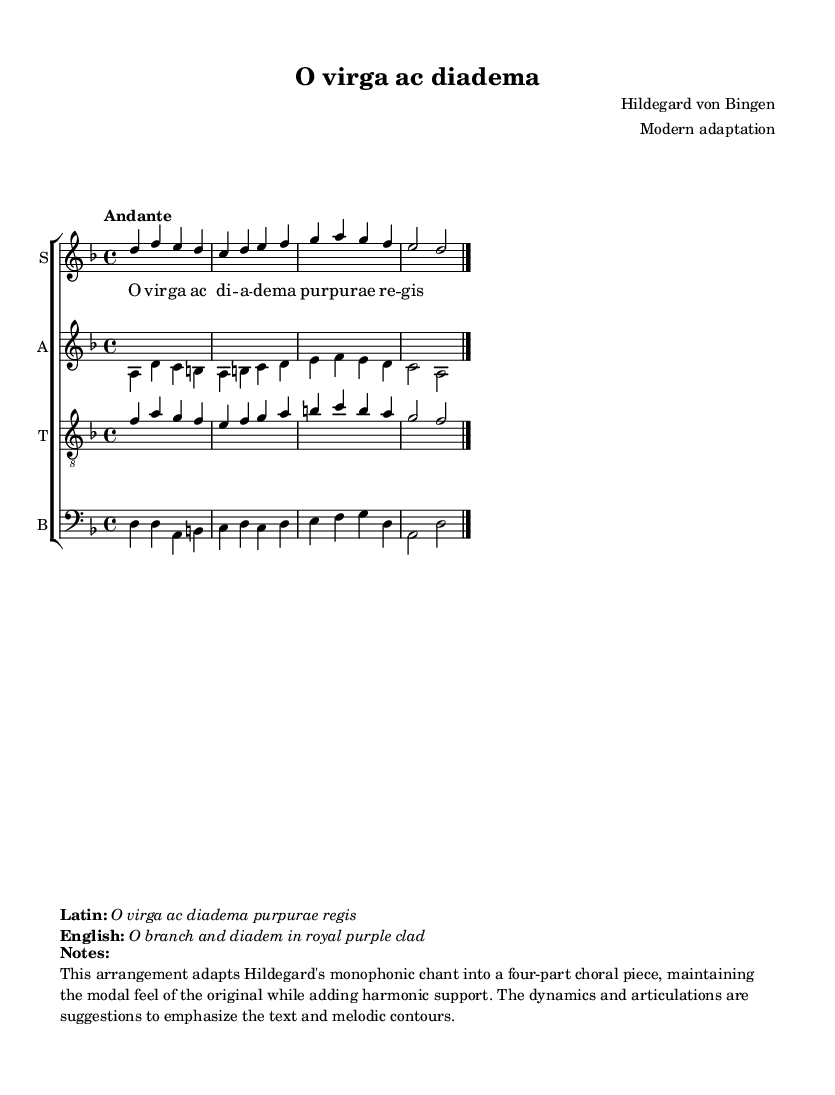What is the key signature of this music? The key signature is indicated at the beginning of the score. It shows two flats, which corresponds to D minor.
Answer: D minor What is the time signature of this score? The time signature is found in the beginning of the music, indicating the number of beats in each measure. Here, it’s written as "4/4," meaning there are four beats per measure.
Answer: 4/4 What is the tempo marking for the piece? The tempo marking is located near the top of the score. It states "Andante," which is an instruction for a moderately slow pace.
Answer: Andante How many parts are arranged in this choral piece? By examining the score, we see that it includes four distinct voice parts: soprano, alto, tenor, and bass as labeled by the staff arrangement.
Answer: Four What is the title of this work? The title is prominently displayed at the top of the music sheet and lists it clearly as "O virga ac diadema."
Answer: O virga ac diadema What do the lyrics of the piece express? The lyrics in Latin "O virga ac diadema purpurae regis" translate to "O branch and diadem in royal purple clad", reflecting themes of divinity and royalty.
Answer: Themes of divinity and royalty What type of musical adaptation does this arrangement represent? This score is an adaptation of Hildegard von Bingen's original monophonic chant, transformed into a four-part choral arrangement, enhancing the work's harmonic depth.
Answer: Four-part choral arrangement 